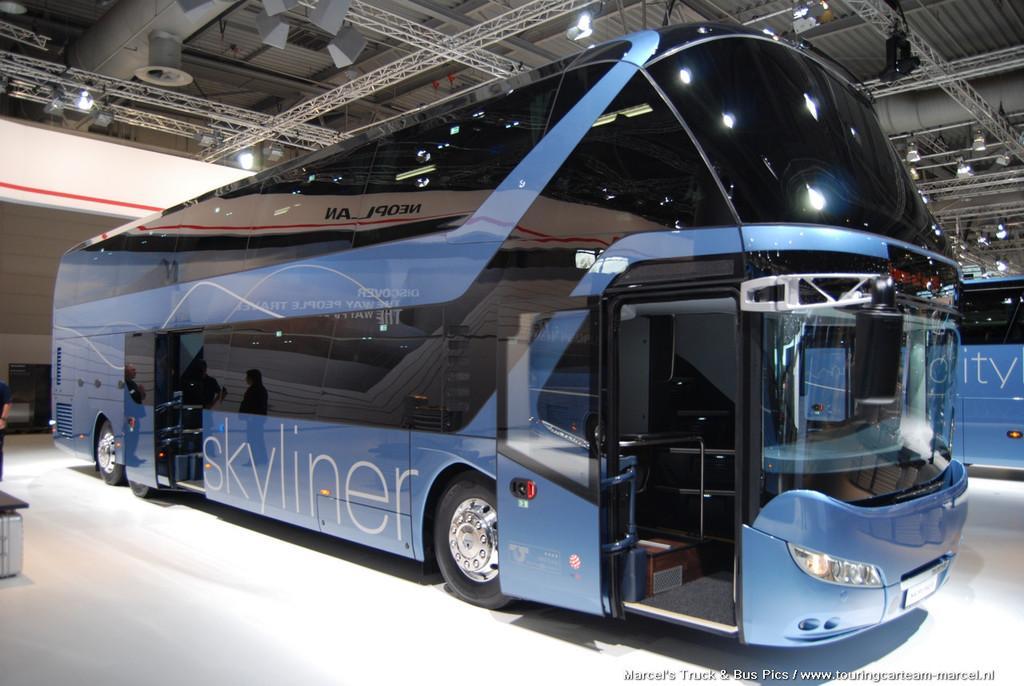Can you describe this image briefly? In this image I can see a blue and black colour bus. On this bus I can see something is written. I can also see reflection of few people over here. In the background I can see number of metal rods, number of lights and one more blue colour bus over there. 